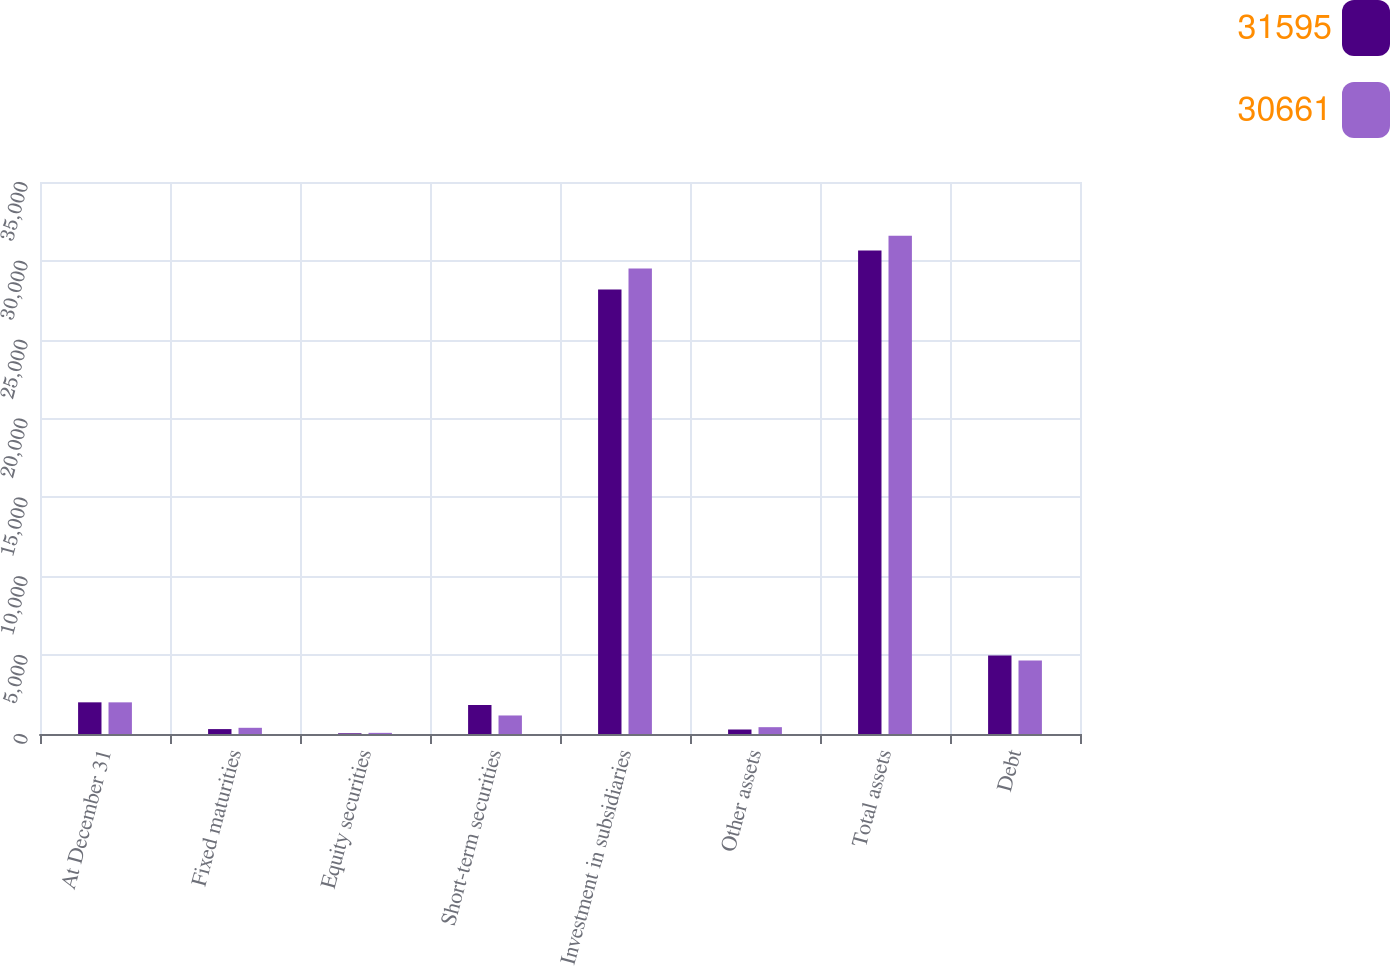Convert chart to OTSL. <chart><loc_0><loc_0><loc_500><loc_500><stacked_bar_chart><ecel><fcel>At December 31<fcel>Fixed maturities<fcel>Equity securities<fcel>Short-term securities<fcel>Investment in subsidiaries<fcel>Other assets<fcel>Total assets<fcel>Debt<nl><fcel>31595<fcel>2008<fcel>311<fcel>44<fcel>1840<fcel>28181<fcel>285<fcel>30661<fcel>4979<nl><fcel>30661<fcel>2007<fcel>393<fcel>72<fcel>1175<fcel>29522<fcel>433<fcel>31595<fcel>4664<nl></chart> 